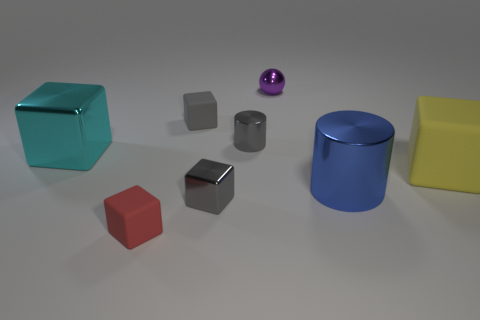How many blocks are to the left of the tiny gray metallic block and behind the small red cube? There is one gray block to the left of the tiny metallic block and directly behind the small red cube. 